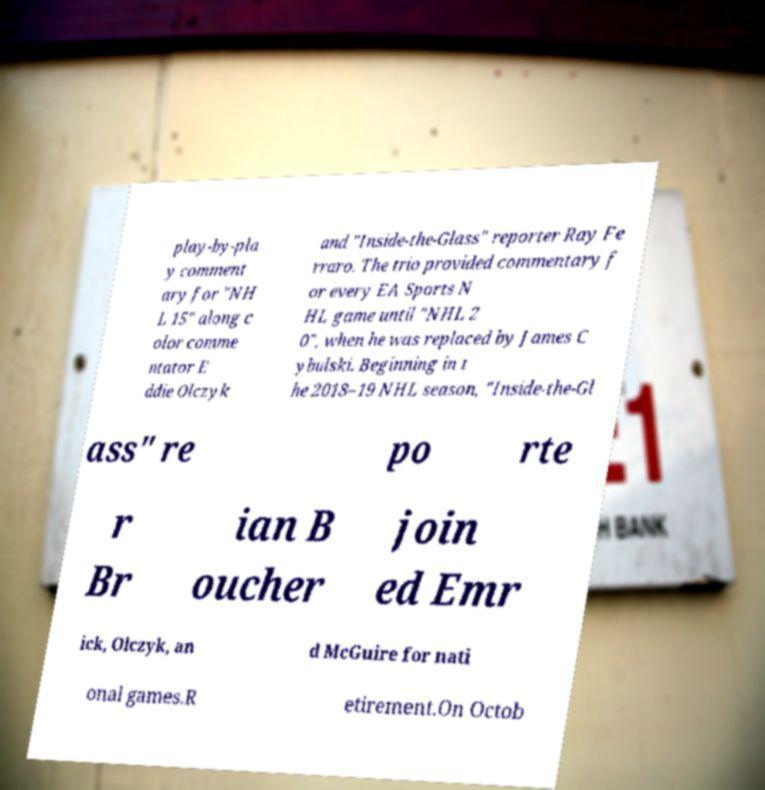Can you read and provide the text displayed in the image?This photo seems to have some interesting text. Can you extract and type it out for me? play-by-pla y comment ary for "NH L 15" along c olor comme ntator E ddie Olczyk and "Inside-the-Glass" reporter Ray Fe rraro. The trio provided commentary f or every EA Sports N HL game until "NHL 2 0", when he was replaced by James C ybulski. Beginning in t he 2018–19 NHL season, "Inside-the-Gl ass" re po rte r Br ian B oucher join ed Emr ick, Olczyk, an d McGuire for nati onal games.R etirement.On Octob 